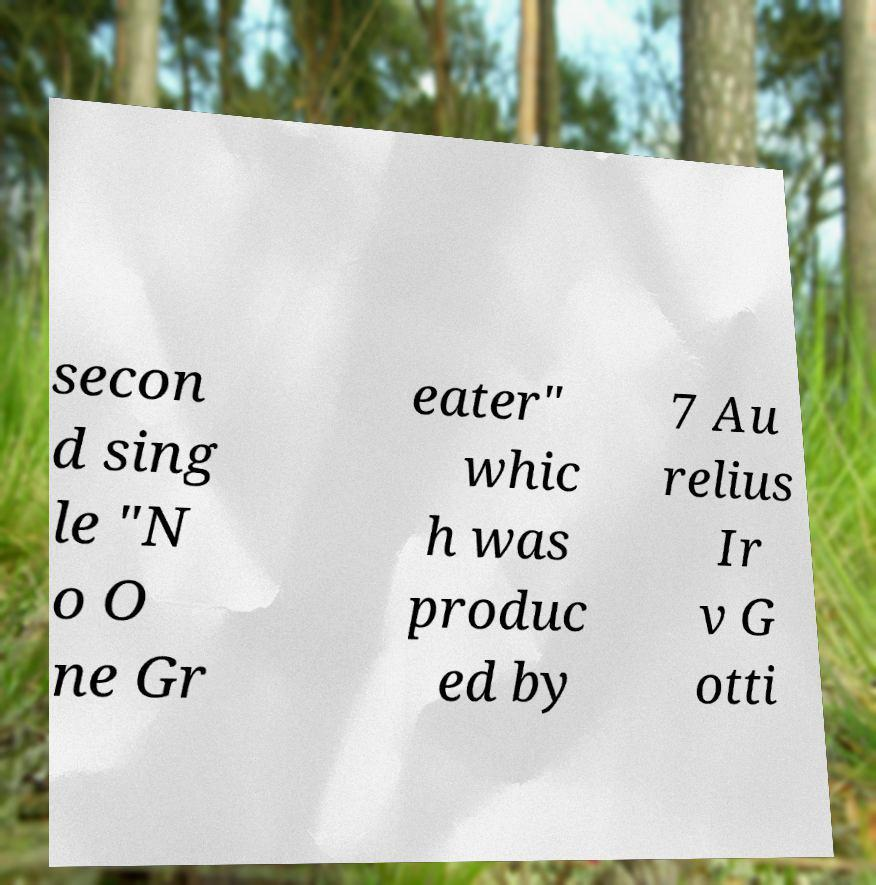For documentation purposes, I need the text within this image transcribed. Could you provide that? secon d sing le "N o O ne Gr eater" whic h was produc ed by 7 Au relius Ir v G otti 